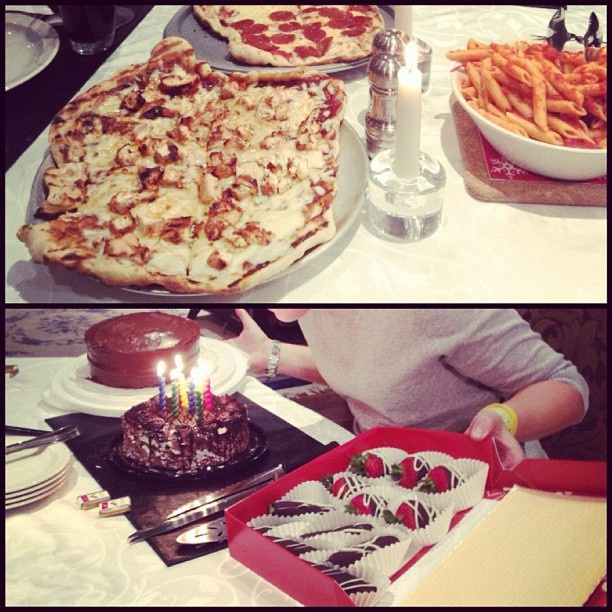Describe the objects in this image and their specific colors. I can see dining table in black, tan, beige, and brown tones, pizza in black, tan, and brown tones, dining table in black, beige, darkgray, and gray tones, people in black, darkgray, tan, brown, and gray tones, and bowl in black, tan, salmon, and darkgray tones in this image. 